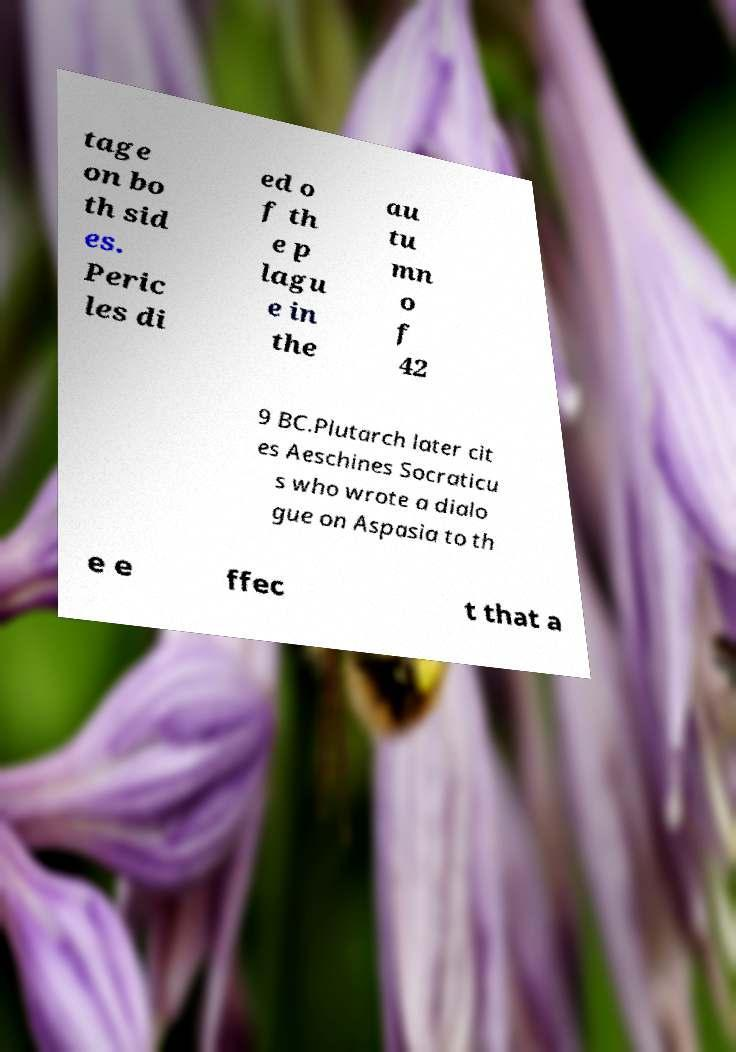Please identify and transcribe the text found in this image. tage on bo th sid es. Peric les di ed o f th e p lagu e in the au tu mn o f 42 9 BC.Plutarch later cit es Aeschines Socraticu s who wrote a dialo gue on Aspasia to th e e ffec t that a 